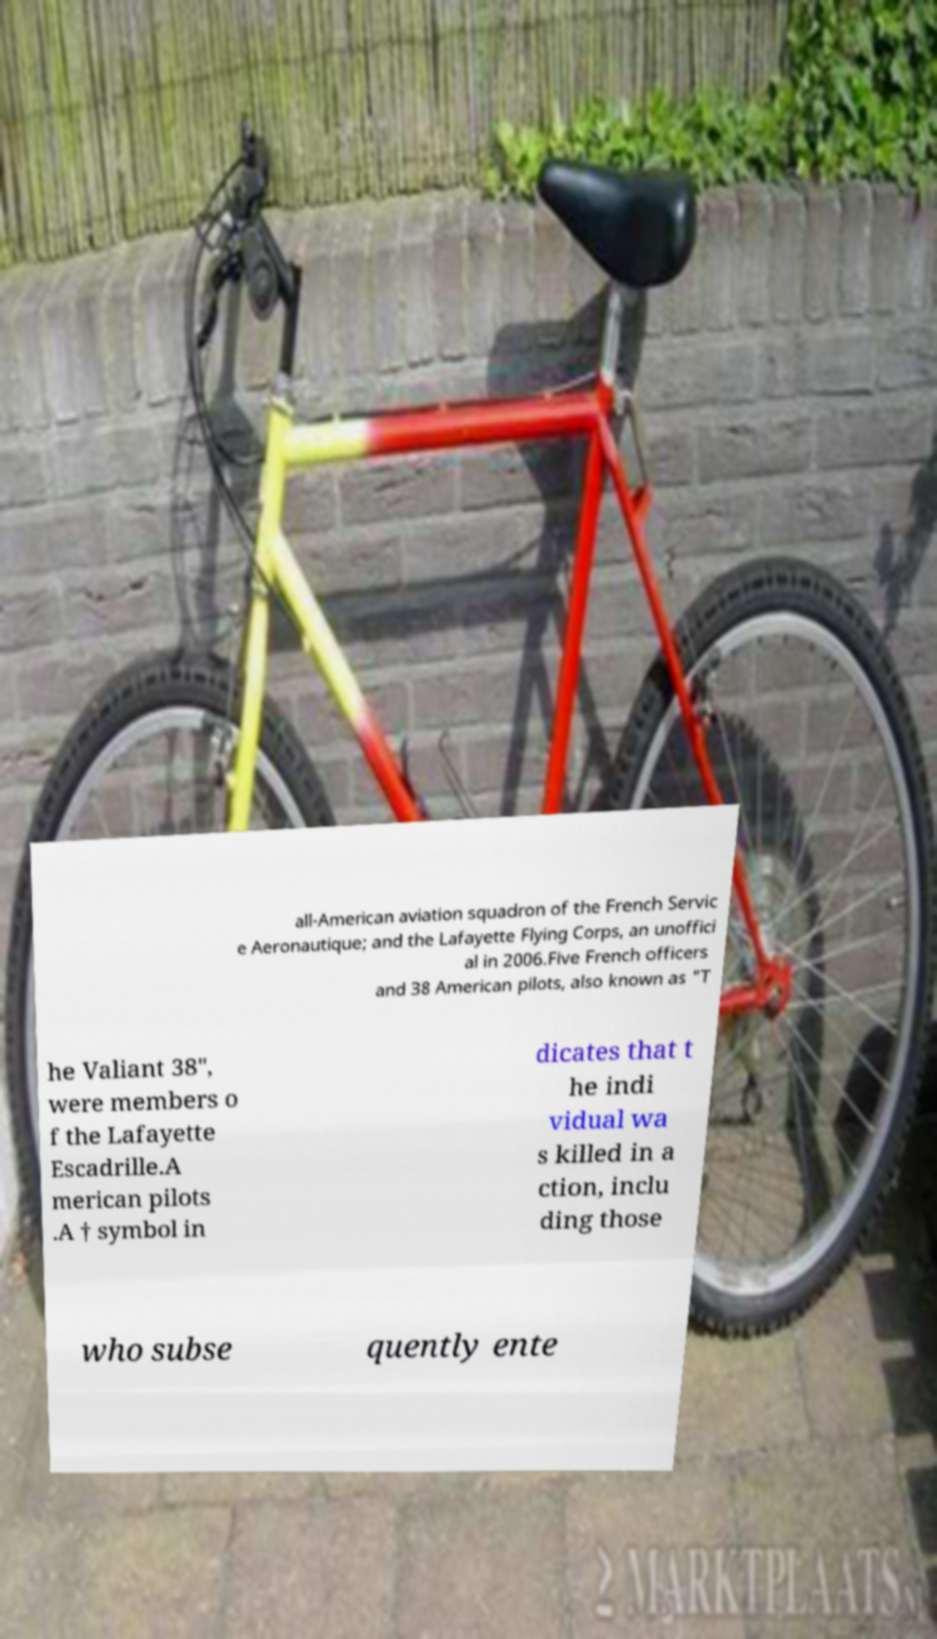What messages or text are displayed in this image? I need them in a readable, typed format. all-American aviation squadron of the French Servic e Aeronautique; and the Lafayette Flying Corps, an unoffici al in 2006.Five French officers and 38 American pilots, also known as "T he Valiant 38", were members o f the Lafayette Escadrille.A merican pilots .A † symbol in dicates that t he indi vidual wa s killed in a ction, inclu ding those who subse quently ente 